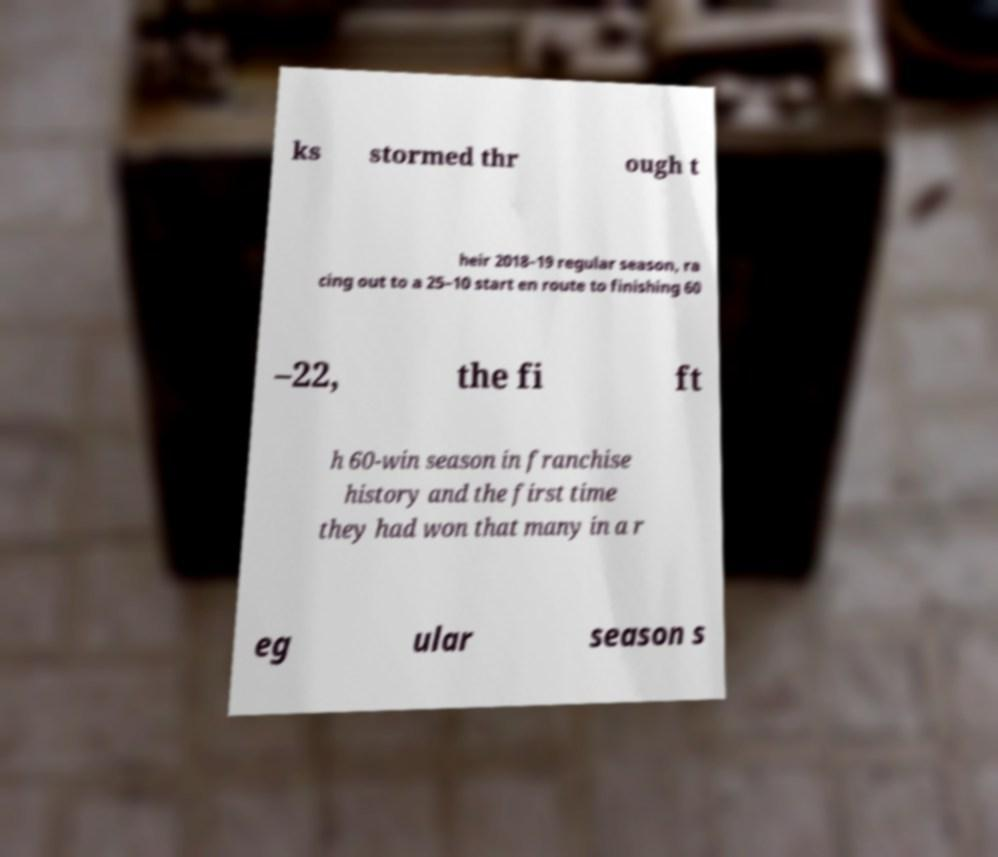Please identify and transcribe the text found in this image. ks stormed thr ough t heir 2018–19 regular season, ra cing out to a 25–10 start en route to finishing 60 –22, the fi ft h 60-win season in franchise history and the first time they had won that many in a r eg ular season s 